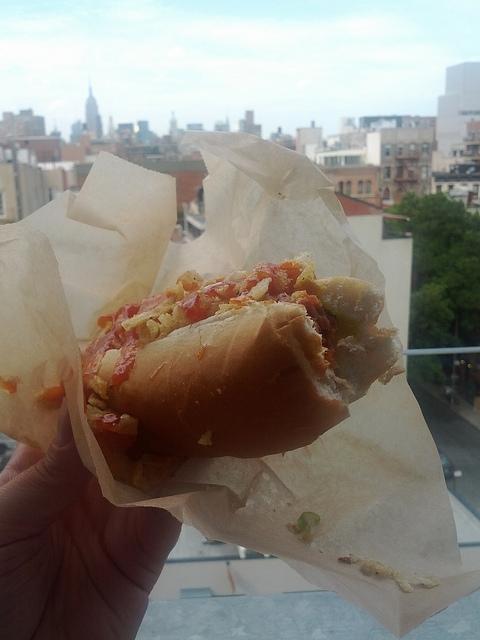How many thumbs are in this picture?
Give a very brief answer. 1. 